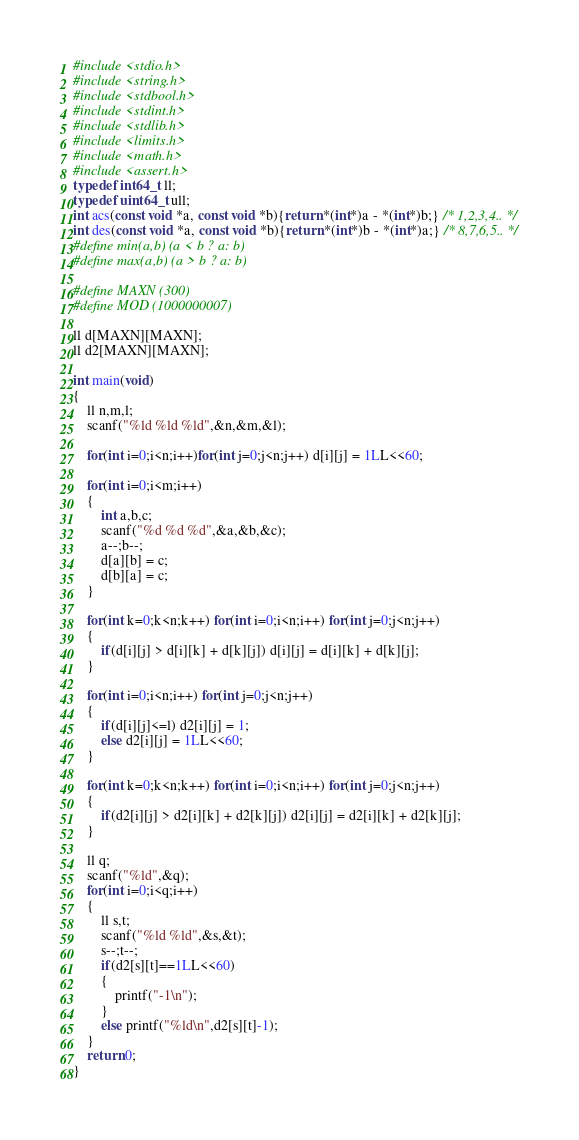Convert code to text. <code><loc_0><loc_0><loc_500><loc_500><_C_>#include <stdio.h>
#include <string.h>
#include <stdbool.h>
#include <stdint.h>
#include <stdlib.h>
#include <limits.h>
#include <math.h>
#include <assert.h>
typedef int64_t ll;
typedef uint64_t ull;
int acs(const void *a, const void *b){return *(int*)a - *(int*)b;} /* 1,2,3,4.. */
int des(const void *a, const void *b){return *(int*)b - *(int*)a;} /* 8,7,6,5.. */
#define min(a,b) (a < b ? a: b)
#define max(a,b) (a > b ? a: b)

#define MAXN (300)
#define MOD (1000000007)

ll d[MAXN][MAXN];
ll d2[MAXN][MAXN];

int main(void)
{
    ll n,m,l;
    scanf("%ld %ld %ld",&n,&m,&l);

    for(int i=0;i<n;i++)for(int j=0;j<n;j++) d[i][j] = 1LL<<60;

    for(int i=0;i<m;i++)
    {
        int a,b,c;
        scanf("%d %d %d",&a,&b,&c);
        a--;b--;
        d[a][b] = c;
        d[b][a] = c;
    }

    for(int k=0;k<n;k++) for(int i=0;i<n;i++) for(int j=0;j<n;j++)
    {
        if(d[i][j] > d[i][k] + d[k][j]) d[i][j] = d[i][k] + d[k][j];
    }

    for(int i=0;i<n;i++) for(int j=0;j<n;j++)
    {
        if(d[i][j]<=l) d2[i][j] = 1;
        else d2[i][j] = 1LL<<60;
    }

    for(int k=0;k<n;k++) for(int i=0;i<n;i++) for(int j=0;j<n;j++)
    {
        if(d2[i][j] > d2[i][k] + d2[k][j]) d2[i][j] = d2[i][k] + d2[k][j];
    }

    ll q;
    scanf("%ld",&q);
    for(int i=0;i<q;i++)
    {
        ll s,t;
        scanf("%ld %ld",&s,&t);
        s--;t--;
        if(d2[s][t]==1LL<<60)
        {
            printf("-1\n");
        }
        else printf("%ld\n",d2[s][t]-1);
    }
    return 0;
}
</code> 